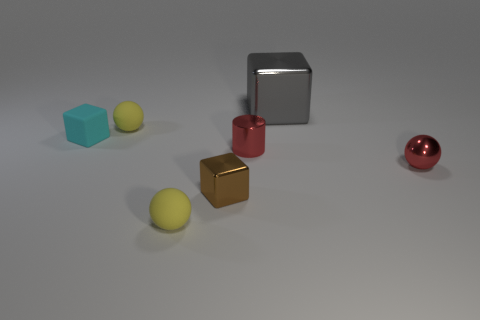What types of materials could these objects be representing? The objects could represent various materials; the large metal cube may represent a polished steel or aluminum. The red and gold cubes, along with the red sphere, might represent painted or anodized metal. The matte blue cube could be a representation of plastic or dyed wood, and the yellow spheres might also be plastic or perhaps rubber due to their matte finish. Are there any shadows visible, and what do they suggest about the lighting? Yes, there are shadows present under each object, suggesting a light source located above the scene, slightly towards the front. The shadows are soft-edged, which could imply a diffused light source like a softbox, commonly used in photography to provide even lighting and reduce harshness. 